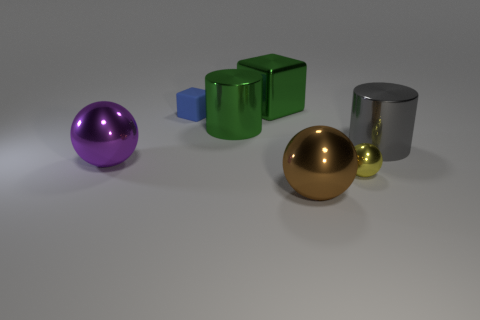How many rubber objects are either large gray things or blue objects?
Offer a terse response. 1. What is the size of the thing to the left of the small blue matte block?
Provide a short and direct response. Large. Is the blue rubber thing the same shape as the large brown thing?
Your response must be concise. No. What number of big objects are either matte cylinders or blue blocks?
Ensure brevity in your answer.  0. Are there any green metallic things right of the small yellow thing?
Keep it short and to the point. No. Is the number of things that are left of the small rubber cube the same as the number of big gray objects?
Offer a very short reply. Yes. What size is the other thing that is the same shape as the small blue thing?
Your answer should be compact. Large. There is a yellow thing; does it have the same shape as the big green shiny thing that is in front of the tiny matte cube?
Provide a succinct answer. No. How big is the purple thing that is to the left of the small object behind the big purple thing?
Offer a very short reply. Large. Are there the same number of metallic cylinders that are to the left of the large brown metallic thing and green cylinders left of the blue object?
Provide a short and direct response. No. 